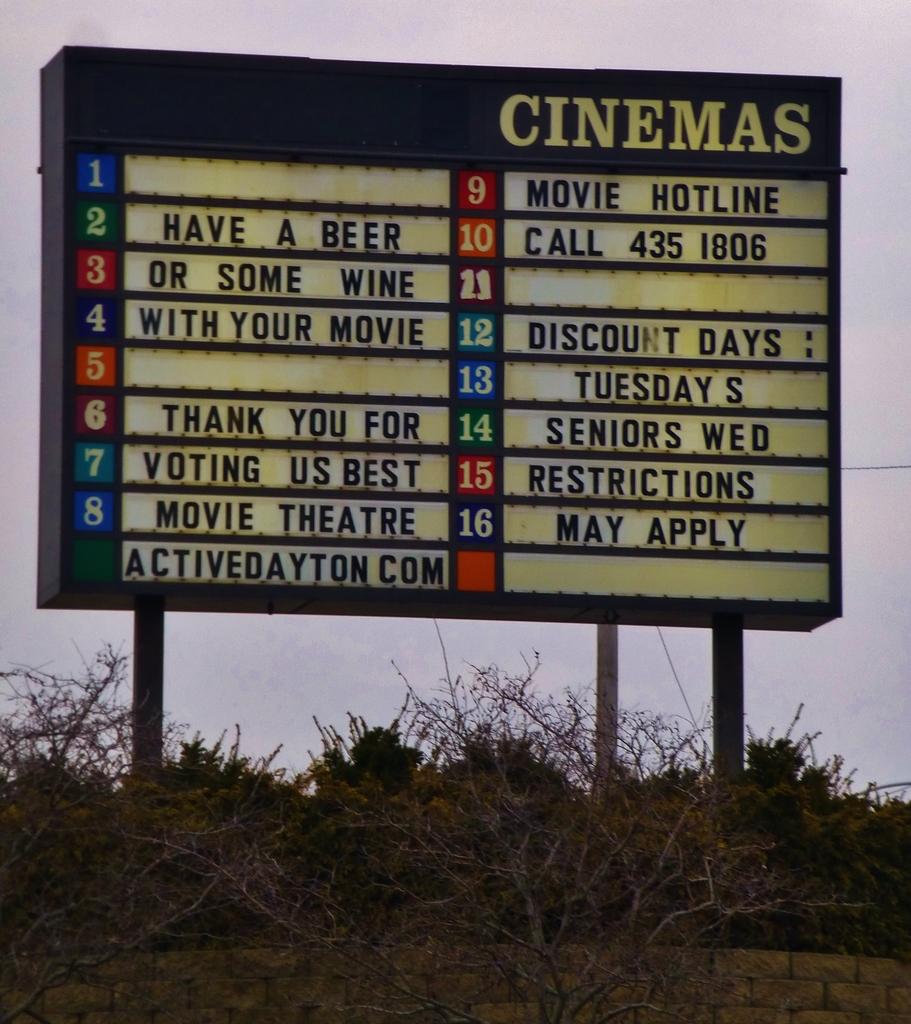What days are discount days at this cinema?
Provide a succinct answer. Tuesdays. Is this cinema located in dayton?
Offer a terse response. Yes. 